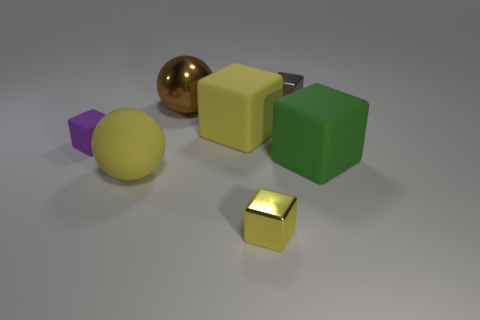Subtract all purple blocks. How many blocks are left? 4 Subtract all purple blocks. How many blocks are left? 4 Subtract all brown blocks. Subtract all blue spheres. How many blocks are left? 5 Add 2 small yellow metal blocks. How many objects exist? 9 Subtract all blocks. How many objects are left? 2 Subtract 0 cyan cylinders. How many objects are left? 7 Subtract all green things. Subtract all large brown things. How many objects are left? 5 Add 4 large things. How many large things are left? 8 Add 2 big red cubes. How many big red cubes exist? 2 